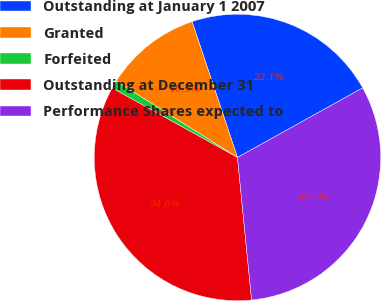<chart> <loc_0><loc_0><loc_500><loc_500><pie_chart><fcel>Outstanding at January 1 2007<fcel>Granted<fcel>Forfeited<fcel>Outstanding at December 31<fcel>Performance Shares expected to<nl><fcel>22.06%<fcel>10.92%<fcel>0.9%<fcel>34.62%<fcel>31.5%<nl></chart> 